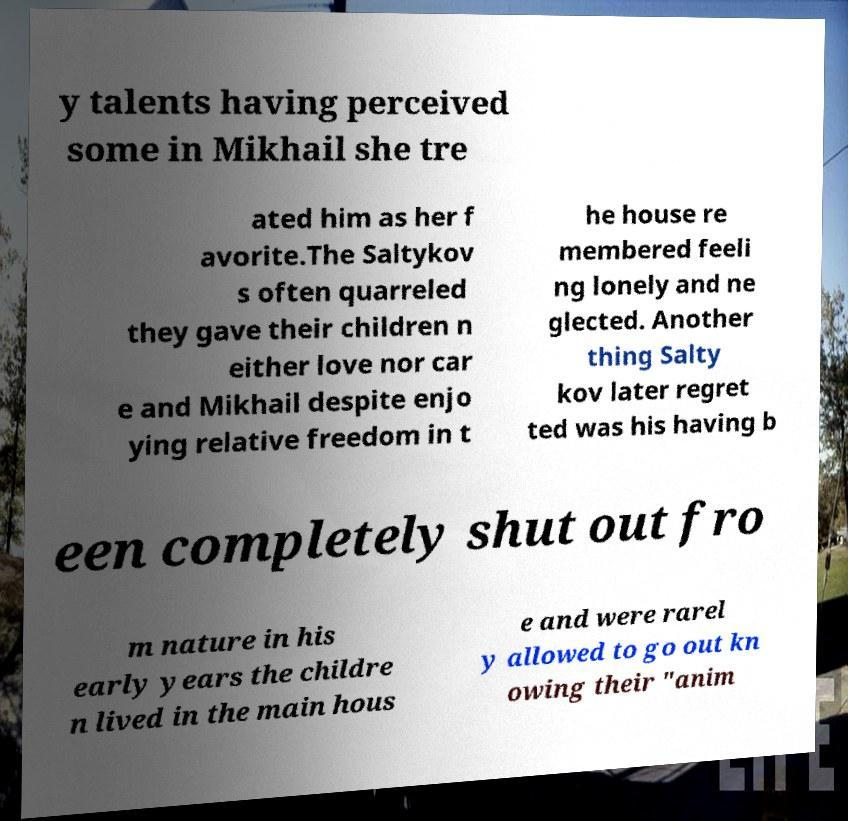Please identify and transcribe the text found in this image. y talents having perceived some in Mikhail she tre ated him as her f avorite.The Saltykov s often quarreled they gave their children n either love nor car e and Mikhail despite enjo ying relative freedom in t he house re membered feeli ng lonely and ne glected. Another thing Salty kov later regret ted was his having b een completely shut out fro m nature in his early years the childre n lived in the main hous e and were rarel y allowed to go out kn owing their "anim 